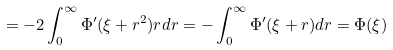Convert formula to latex. <formula><loc_0><loc_0><loc_500><loc_500>= - 2 \int _ { 0 } ^ { \infty } \Phi ^ { \prime } ( \xi + r ^ { 2 } ) r d r = - \int _ { 0 } ^ { \infty } \Phi ^ { \prime } ( \xi + r ) d r = \Phi ( \xi )</formula> 